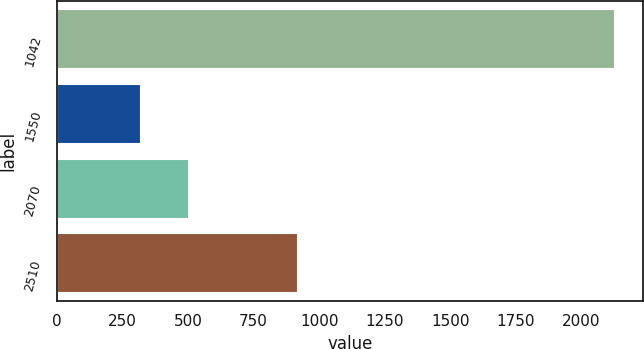Convert chart. <chart><loc_0><loc_0><loc_500><loc_500><bar_chart><fcel>1042<fcel>1550<fcel>2070<fcel>2510<nl><fcel>2128<fcel>322<fcel>502.6<fcel>918<nl></chart> 